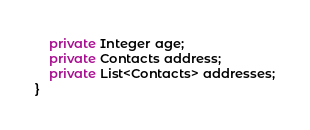Convert code to text. <code><loc_0><loc_0><loc_500><loc_500><_Java_>    private Integer age;
    private Contacts address;
    private List<Contacts> addresses;
}
</code> 